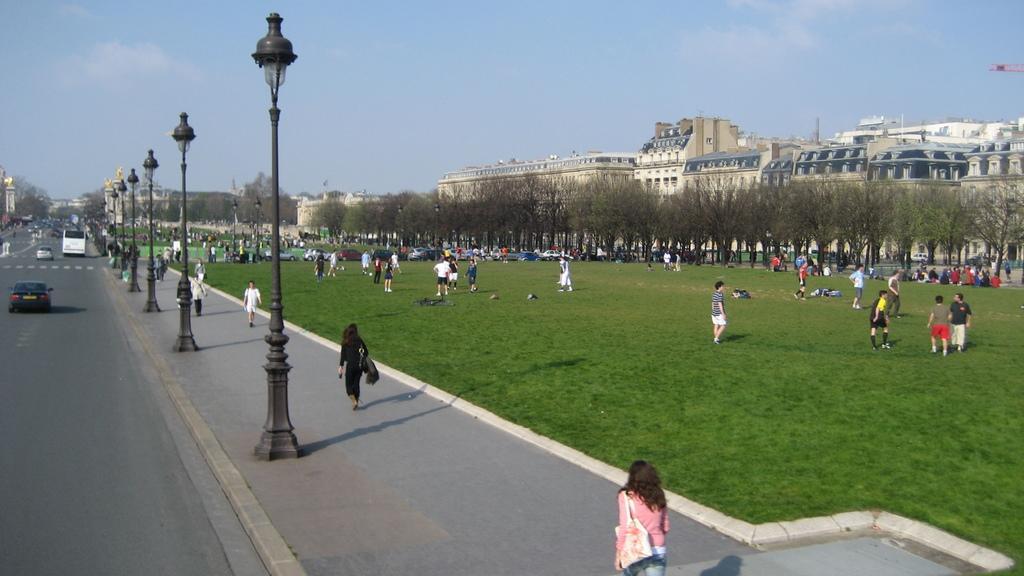In one or two sentences, can you explain what this image depicts? In the image there are many persons walking on the footpath with street lights in front of it, on left side there are many vehicles moving on road, on right side there is a garden with many people and cars all over it followed by trees and buildings in the background and above its sky. 